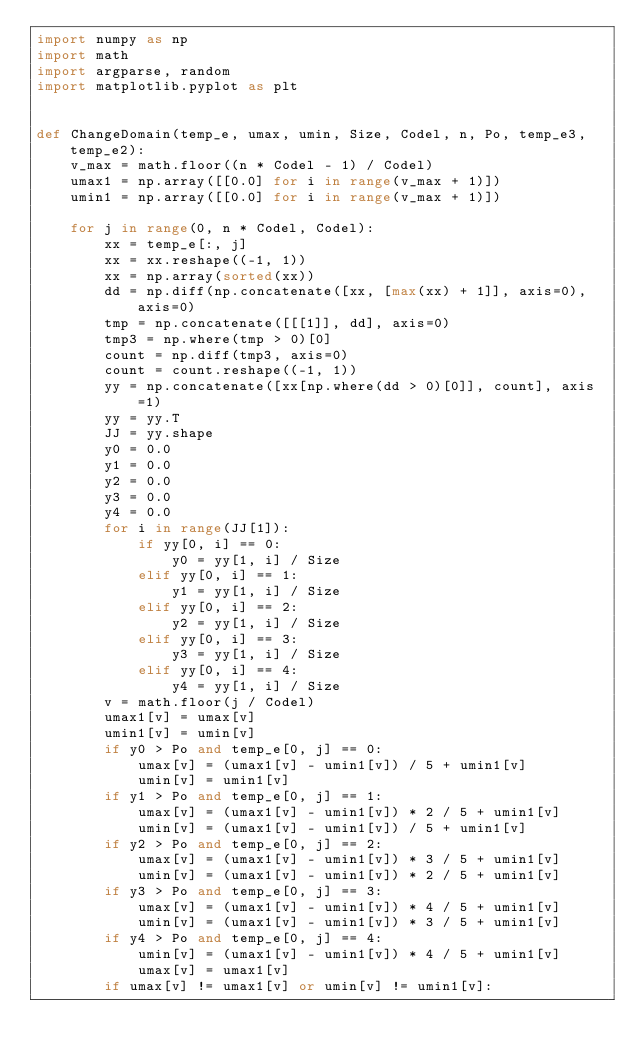<code> <loc_0><loc_0><loc_500><loc_500><_Python_>import numpy as np
import math
import argparse, random
import matplotlib.pyplot as plt


def ChangeDomain(temp_e, umax, umin, Size, Codel, n, Po, temp_e3, temp_e2):
    v_max = math.floor((n * Codel - 1) / Codel)
    umax1 = np.array([[0.0] for i in range(v_max + 1)])
    umin1 = np.array([[0.0] for i in range(v_max + 1)])

    for j in range(0, n * Codel, Codel):
        xx = temp_e[:, j]
        xx = xx.reshape((-1, 1))
        xx = np.array(sorted(xx))
        dd = np.diff(np.concatenate([xx, [max(xx) + 1]], axis=0), axis=0)
        tmp = np.concatenate([[[1]], dd], axis=0)
        tmp3 = np.where(tmp > 0)[0]
        count = np.diff(tmp3, axis=0)
        count = count.reshape((-1, 1))
        yy = np.concatenate([xx[np.where(dd > 0)[0]], count], axis=1)
        yy = yy.T
        JJ = yy.shape
        y0 = 0.0
        y1 = 0.0
        y2 = 0.0
        y3 = 0.0
        y4 = 0.0
        for i in range(JJ[1]):
            if yy[0, i] == 0:
                y0 = yy[1, i] / Size
            elif yy[0, i] == 1:
                y1 = yy[1, i] / Size
            elif yy[0, i] == 2:
                y2 = yy[1, i] / Size
            elif yy[0, i] == 3:
                y3 = yy[1, i] / Size
            elif yy[0, i] == 4:
                y4 = yy[1, i] / Size
        v = math.floor(j / Codel)
        umax1[v] = umax[v]
        umin1[v] = umin[v]
        if y0 > Po and temp_e[0, j] == 0:
            umax[v] = (umax1[v] - umin1[v]) / 5 + umin1[v]
            umin[v] = umin1[v]
        if y1 > Po and temp_e[0, j] == 1:
            umax[v] = (umax1[v] - umin1[v]) * 2 / 5 + umin1[v]
            umin[v] = (umax1[v] - umin1[v]) / 5 + umin1[v]
        if y2 > Po and temp_e[0, j] == 2:
            umax[v] = (umax1[v] - umin1[v]) * 3 / 5 + umin1[v]
            umin[v] = (umax1[v] - umin1[v]) * 2 / 5 + umin1[v]
        if y3 > Po and temp_e[0, j] == 3:
            umax[v] = (umax1[v] - umin1[v]) * 4 / 5 + umin1[v]
            umin[v] = (umax1[v] - umin1[v]) * 3 / 5 + umin1[v]
        if y4 > Po and temp_e[0, j] == 4:
            umin[v] = (umax1[v] - umin1[v]) * 4 / 5 + umin1[v]
            umax[v] = umax1[v]
        if umax[v] != umax1[v] or umin[v] != umin1[v]:</code> 